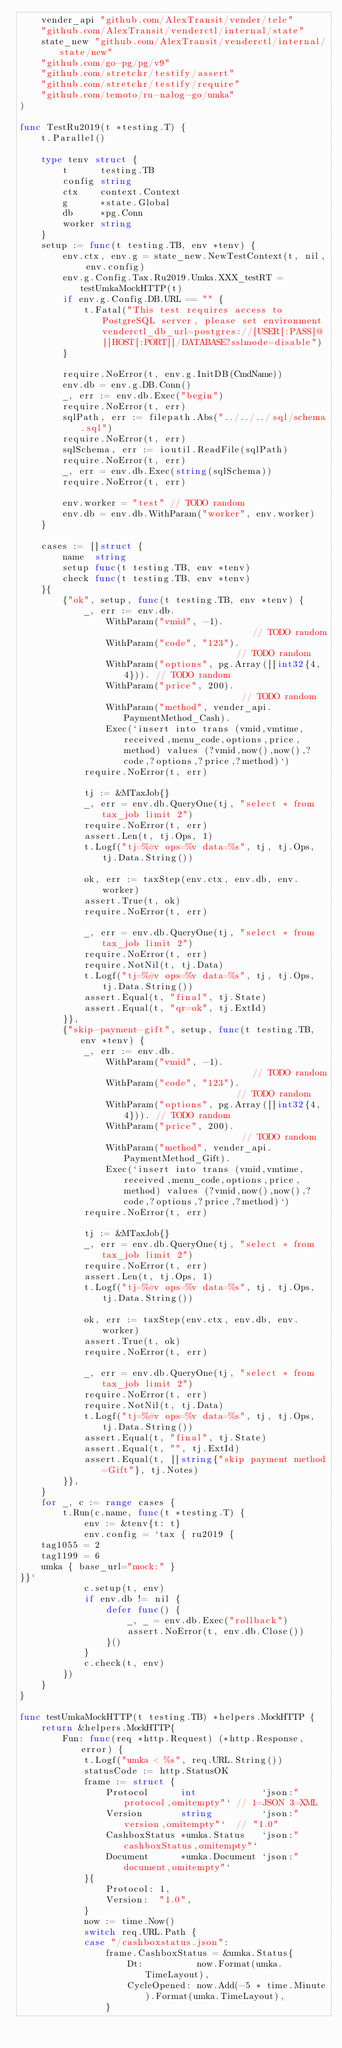<code> <loc_0><loc_0><loc_500><loc_500><_Go_>	vender_api "github.com/AlexTransit/vender/tele"
	"github.com/AlexTransit/venderctl/internal/state"
	state_new "github.com/AlexTransit/venderctl/internal/state/new"
	"github.com/go-pg/pg/v9"
	"github.com/stretchr/testify/assert"
	"github.com/stretchr/testify/require"
	"github.com/temoto/ru-nalog-go/umka"
)

func TestRu2019(t *testing.T) {
	t.Parallel()

	type tenv struct {
		t      testing.TB
		config string
		ctx    context.Context
		g      *state.Global
		db     *pg.Conn
		worker string
	}
	setup := func(t testing.TB, env *tenv) {
		env.ctx, env.g = state_new.NewTestContext(t, nil, env.config)
		env.g.Config.Tax.Ru2019.Umka.XXX_testRT = testUmkaMockHTTP(t)
		if env.g.Config.DB.URL == "" {
			t.Fatal("This test requires access to PostgreSQL server, please set environment venderctl_db_url=postgres://[USER[:PASS]@][HOST[:PORT]]/DATABASE?sslmode=disable")
		}

		require.NoError(t, env.g.InitDB(CmdName))
		env.db = env.g.DB.Conn()
		_, err := env.db.Exec("begin")
		require.NoError(t, err)
		sqlPath, err := filepath.Abs("../../../sql/schema.sql")
		require.NoError(t, err)
		sqlSchema, err := ioutil.ReadFile(sqlPath)
		require.NoError(t, err)
		_, err = env.db.Exec(string(sqlSchema))
		require.NoError(t, err)

		env.worker = "test" // TODO random
		env.db = env.db.WithParam("worker", env.worker)
	}

	cases := []struct {
		name  string
		setup func(t testing.TB, env *tenv)
		check func(t testing.TB, env *tenv)
	}{
		{"ok", setup, func(t testing.TB, env *tenv) {
			_, err := env.db.
				WithParam("vmid", -1).                         // TODO random
				WithParam("code", "123").                      // TODO random
				WithParam("options", pg.Array([]int32{4, 4})). // TODO random
				WithParam("price", 200).                       // TODO random
				WithParam("method", vender_api.PaymentMethod_Cash).
				Exec(`insert into trans (vmid,vmtime,received,menu_code,options,price,method) values (?vmid,now(),now(),?code,?options,?price,?method)`)
			require.NoError(t, err)

			tj := &MTaxJob{}
			_, err = env.db.QueryOne(tj, "select * from tax_job limit 2")
			require.NoError(t, err)
			assert.Len(t, tj.Ops, 1)
			t.Logf("tj=%#v ops=%v data=%s", tj, tj.Ops, tj.Data.String())

			ok, err := taxStep(env.ctx, env.db, env.worker)
			assert.True(t, ok)
			require.NoError(t, err)

			_, err = env.db.QueryOne(tj, "select * from tax_job limit 2")
			require.NoError(t, err)
			require.NotNil(t, tj.Data)
			t.Logf("tj=%#v ops=%v data=%s", tj, tj.Ops, tj.Data.String())
			assert.Equal(t, "final", tj.State)
			assert.Equal(t, "qr=ok", tj.ExtId)
		}},
		{"skip-payment-gift", setup, func(t testing.TB, env *tenv) {
			_, err := env.db.
				WithParam("vmid", -1).                         // TODO random
				WithParam("code", "123").                      // TODO random
				WithParam("options", pg.Array([]int32{4, 4})). // TODO random
				WithParam("price", 200).                       // TODO random
				WithParam("method", vender_api.PaymentMethod_Gift).
				Exec(`insert into trans (vmid,vmtime,received,menu_code,options,price,method) values (?vmid,now(),now(),?code,?options,?price,?method)`)
			require.NoError(t, err)

			tj := &MTaxJob{}
			_, err = env.db.QueryOne(tj, "select * from tax_job limit 2")
			require.NoError(t, err)
			assert.Len(t, tj.Ops, 1)
			t.Logf("tj=%#v ops=%v data=%s", tj, tj.Ops, tj.Data.String())

			ok, err := taxStep(env.ctx, env.db, env.worker)
			assert.True(t, ok)
			require.NoError(t, err)

			_, err = env.db.QueryOne(tj, "select * from tax_job limit 2")
			require.NoError(t, err)
			require.NotNil(t, tj.Data)
			t.Logf("tj=%#v ops=%v data=%s", tj, tj.Ops, tj.Data.String())
			assert.Equal(t, "final", tj.State)
			assert.Equal(t, "", tj.ExtId)
			assert.Equal(t, []string{"skip payment method=Gift"}, tj.Notes)
		}},
	}
	for _, c := range cases {
		t.Run(c.name, func(t *testing.T) {
			env := &tenv{t: t}
			env.config = `tax { ru2019 {
	tag1055 = 2
	tag1199 = 6
	umka { base_url="mock:" }
}}`
			c.setup(t, env)
			if env.db != nil {
				defer func() {
					_, _ = env.db.Exec("rollback")
					assert.NoError(t, env.db.Close())
				}()
			}
			c.check(t, env)
		})
	}
}

func testUmkaMockHTTP(t testing.TB) *helpers.MockHTTP {
	return &helpers.MockHTTP{
		Fun: func(req *http.Request) (*http.Response, error) {
			t.Logf("umka < %s", req.URL.String())
			statusCode := http.StatusOK
			frame := struct {
				Protocol      int            `json:"protocol,omitempty"` // 1=JSON 3=XML
				Version       string         `json:"version,omitempty"`  // "1.0"
				CashboxStatus *umka.Status   `json:"cashboxStatus,omitempty"`
				Document      *umka.Document `json:"document,omitempty"`
			}{
				Protocol: 1,
				Version:  "1.0",
			}
			now := time.Now()
			switch req.URL.Path {
			case "/cashboxstatus.json":
				frame.CashboxStatus = &umka.Status{
					Dt:          now.Format(umka.TimeLayout),
					CycleOpened: now.Add(-5 * time.Minute).Format(umka.TimeLayout),
				}</code> 